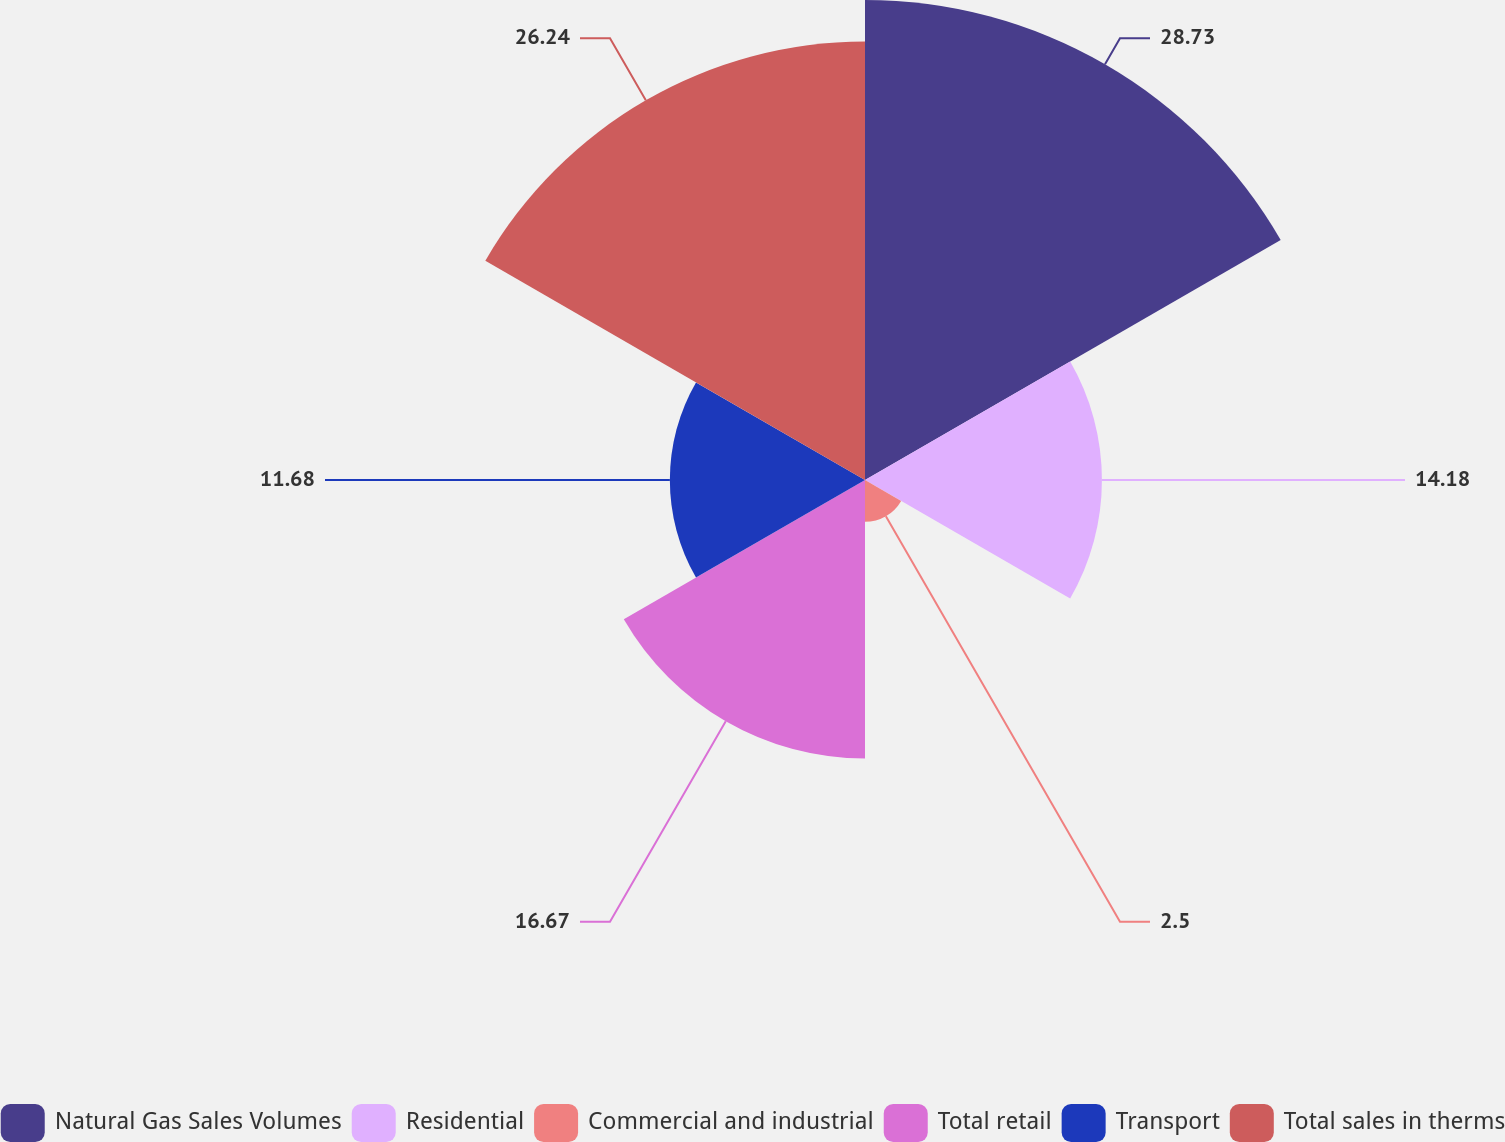Convert chart. <chart><loc_0><loc_0><loc_500><loc_500><pie_chart><fcel>Natural Gas Sales Volumes<fcel>Residential<fcel>Commercial and industrial<fcel>Total retail<fcel>Transport<fcel>Total sales in therms<nl><fcel>28.73%<fcel>14.18%<fcel>2.5%<fcel>16.67%<fcel>11.68%<fcel>26.24%<nl></chart> 